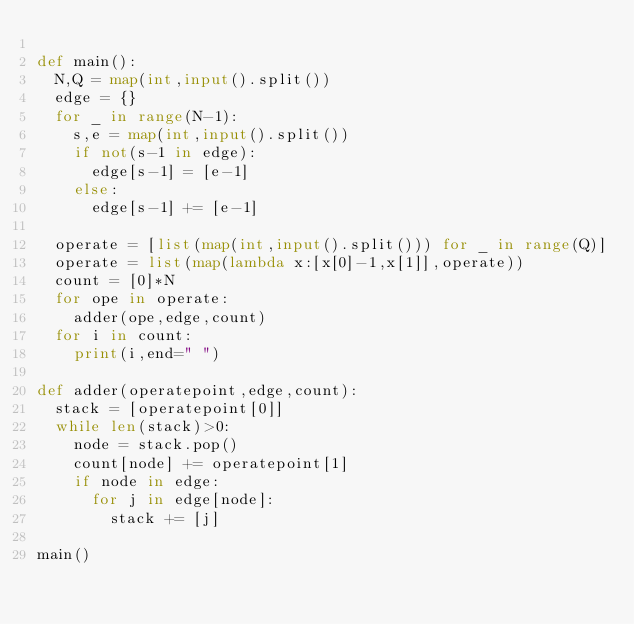Convert code to text. <code><loc_0><loc_0><loc_500><loc_500><_Python_>
def main():
  N,Q = map(int,input().split())
  edge = {}
  for _ in range(N-1):
    s,e = map(int,input().split())
    if not(s-1 in edge):
      edge[s-1] = [e-1]
    else:
      edge[s-1] += [e-1]

  operate = [list(map(int,input().split())) for _ in range(Q)]
  operate = list(map(lambda x:[x[0]-1,x[1]],operate))
  count = [0]*N
  for ope in operate:
    adder(ope,edge,count)
  for i in count:
    print(i,end=" ")

def adder(operatepoint,edge,count):
  stack = [operatepoint[0]]
  while len(stack)>0:
    node = stack.pop()
    count[node] += operatepoint[1]
    if node in edge:
      for j in edge[node]:
        stack += [j]

main()</code> 